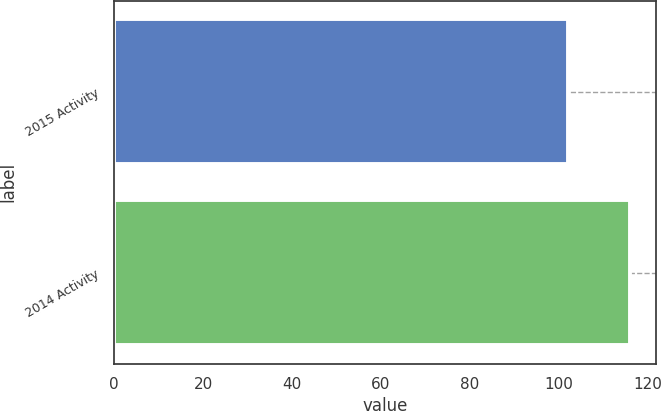<chart> <loc_0><loc_0><loc_500><loc_500><bar_chart><fcel>2015 Activity<fcel>2014 Activity<nl><fcel>102<fcel>116<nl></chart> 